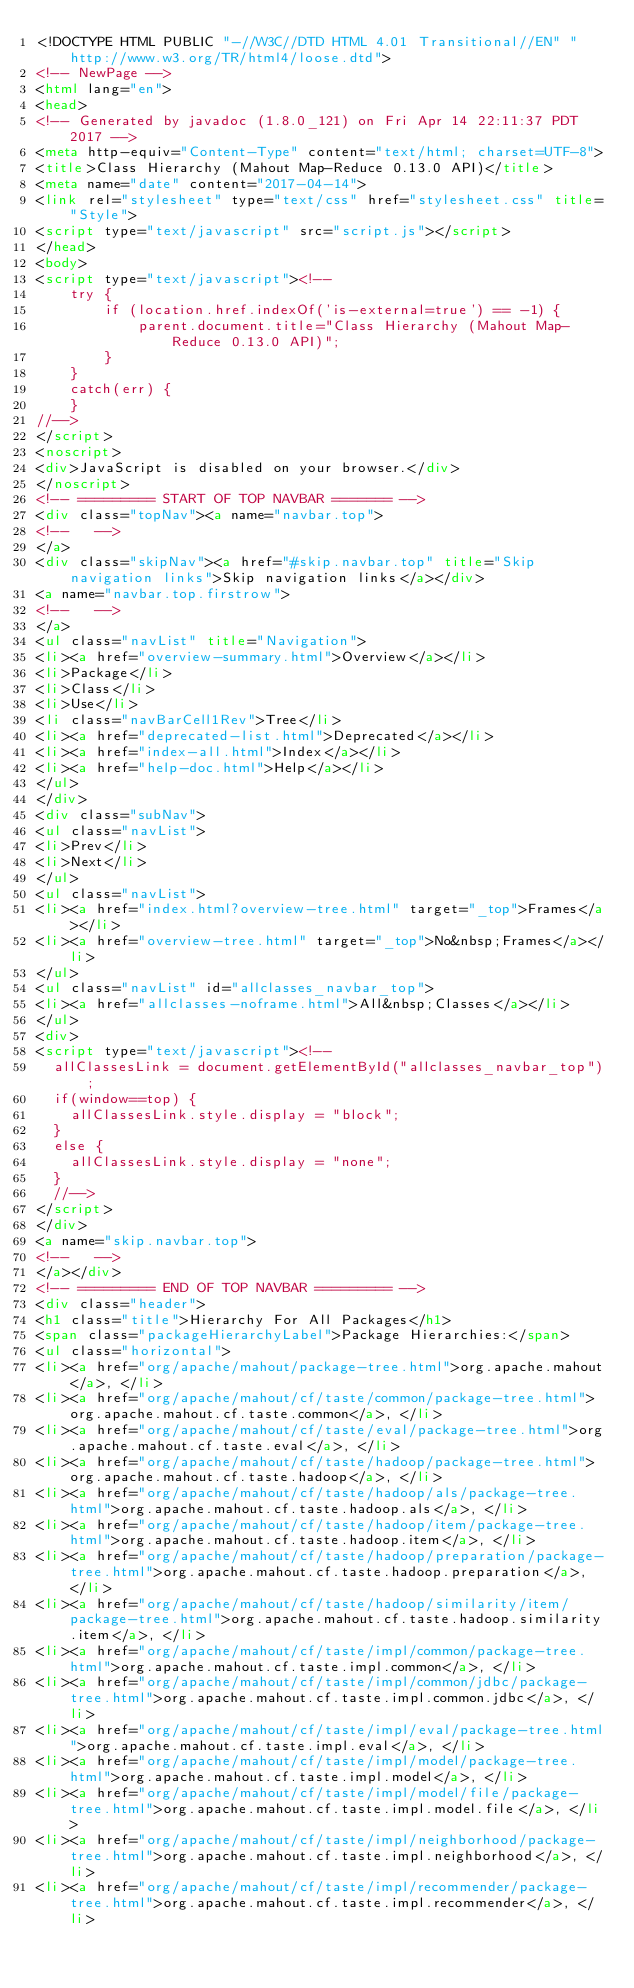Convert code to text. <code><loc_0><loc_0><loc_500><loc_500><_HTML_><!DOCTYPE HTML PUBLIC "-//W3C//DTD HTML 4.01 Transitional//EN" "http://www.w3.org/TR/html4/loose.dtd">
<!-- NewPage -->
<html lang="en">
<head>
<!-- Generated by javadoc (1.8.0_121) on Fri Apr 14 22:11:37 PDT 2017 -->
<meta http-equiv="Content-Type" content="text/html; charset=UTF-8">
<title>Class Hierarchy (Mahout Map-Reduce 0.13.0 API)</title>
<meta name="date" content="2017-04-14">
<link rel="stylesheet" type="text/css" href="stylesheet.css" title="Style">
<script type="text/javascript" src="script.js"></script>
</head>
<body>
<script type="text/javascript"><!--
    try {
        if (location.href.indexOf('is-external=true') == -1) {
            parent.document.title="Class Hierarchy (Mahout Map-Reduce 0.13.0 API)";
        }
    }
    catch(err) {
    }
//-->
</script>
<noscript>
<div>JavaScript is disabled on your browser.</div>
</noscript>
<!-- ========= START OF TOP NAVBAR ======= -->
<div class="topNav"><a name="navbar.top">
<!--   -->
</a>
<div class="skipNav"><a href="#skip.navbar.top" title="Skip navigation links">Skip navigation links</a></div>
<a name="navbar.top.firstrow">
<!--   -->
</a>
<ul class="navList" title="Navigation">
<li><a href="overview-summary.html">Overview</a></li>
<li>Package</li>
<li>Class</li>
<li>Use</li>
<li class="navBarCell1Rev">Tree</li>
<li><a href="deprecated-list.html">Deprecated</a></li>
<li><a href="index-all.html">Index</a></li>
<li><a href="help-doc.html">Help</a></li>
</ul>
</div>
<div class="subNav">
<ul class="navList">
<li>Prev</li>
<li>Next</li>
</ul>
<ul class="navList">
<li><a href="index.html?overview-tree.html" target="_top">Frames</a></li>
<li><a href="overview-tree.html" target="_top">No&nbsp;Frames</a></li>
</ul>
<ul class="navList" id="allclasses_navbar_top">
<li><a href="allclasses-noframe.html">All&nbsp;Classes</a></li>
</ul>
<div>
<script type="text/javascript"><!--
  allClassesLink = document.getElementById("allclasses_navbar_top");
  if(window==top) {
    allClassesLink.style.display = "block";
  }
  else {
    allClassesLink.style.display = "none";
  }
  //-->
</script>
</div>
<a name="skip.navbar.top">
<!--   -->
</a></div>
<!-- ========= END OF TOP NAVBAR ========= -->
<div class="header">
<h1 class="title">Hierarchy For All Packages</h1>
<span class="packageHierarchyLabel">Package Hierarchies:</span>
<ul class="horizontal">
<li><a href="org/apache/mahout/package-tree.html">org.apache.mahout</a>, </li>
<li><a href="org/apache/mahout/cf/taste/common/package-tree.html">org.apache.mahout.cf.taste.common</a>, </li>
<li><a href="org/apache/mahout/cf/taste/eval/package-tree.html">org.apache.mahout.cf.taste.eval</a>, </li>
<li><a href="org/apache/mahout/cf/taste/hadoop/package-tree.html">org.apache.mahout.cf.taste.hadoop</a>, </li>
<li><a href="org/apache/mahout/cf/taste/hadoop/als/package-tree.html">org.apache.mahout.cf.taste.hadoop.als</a>, </li>
<li><a href="org/apache/mahout/cf/taste/hadoop/item/package-tree.html">org.apache.mahout.cf.taste.hadoop.item</a>, </li>
<li><a href="org/apache/mahout/cf/taste/hadoop/preparation/package-tree.html">org.apache.mahout.cf.taste.hadoop.preparation</a>, </li>
<li><a href="org/apache/mahout/cf/taste/hadoop/similarity/item/package-tree.html">org.apache.mahout.cf.taste.hadoop.similarity.item</a>, </li>
<li><a href="org/apache/mahout/cf/taste/impl/common/package-tree.html">org.apache.mahout.cf.taste.impl.common</a>, </li>
<li><a href="org/apache/mahout/cf/taste/impl/common/jdbc/package-tree.html">org.apache.mahout.cf.taste.impl.common.jdbc</a>, </li>
<li><a href="org/apache/mahout/cf/taste/impl/eval/package-tree.html">org.apache.mahout.cf.taste.impl.eval</a>, </li>
<li><a href="org/apache/mahout/cf/taste/impl/model/package-tree.html">org.apache.mahout.cf.taste.impl.model</a>, </li>
<li><a href="org/apache/mahout/cf/taste/impl/model/file/package-tree.html">org.apache.mahout.cf.taste.impl.model.file</a>, </li>
<li><a href="org/apache/mahout/cf/taste/impl/neighborhood/package-tree.html">org.apache.mahout.cf.taste.impl.neighborhood</a>, </li>
<li><a href="org/apache/mahout/cf/taste/impl/recommender/package-tree.html">org.apache.mahout.cf.taste.impl.recommender</a>, </li></code> 